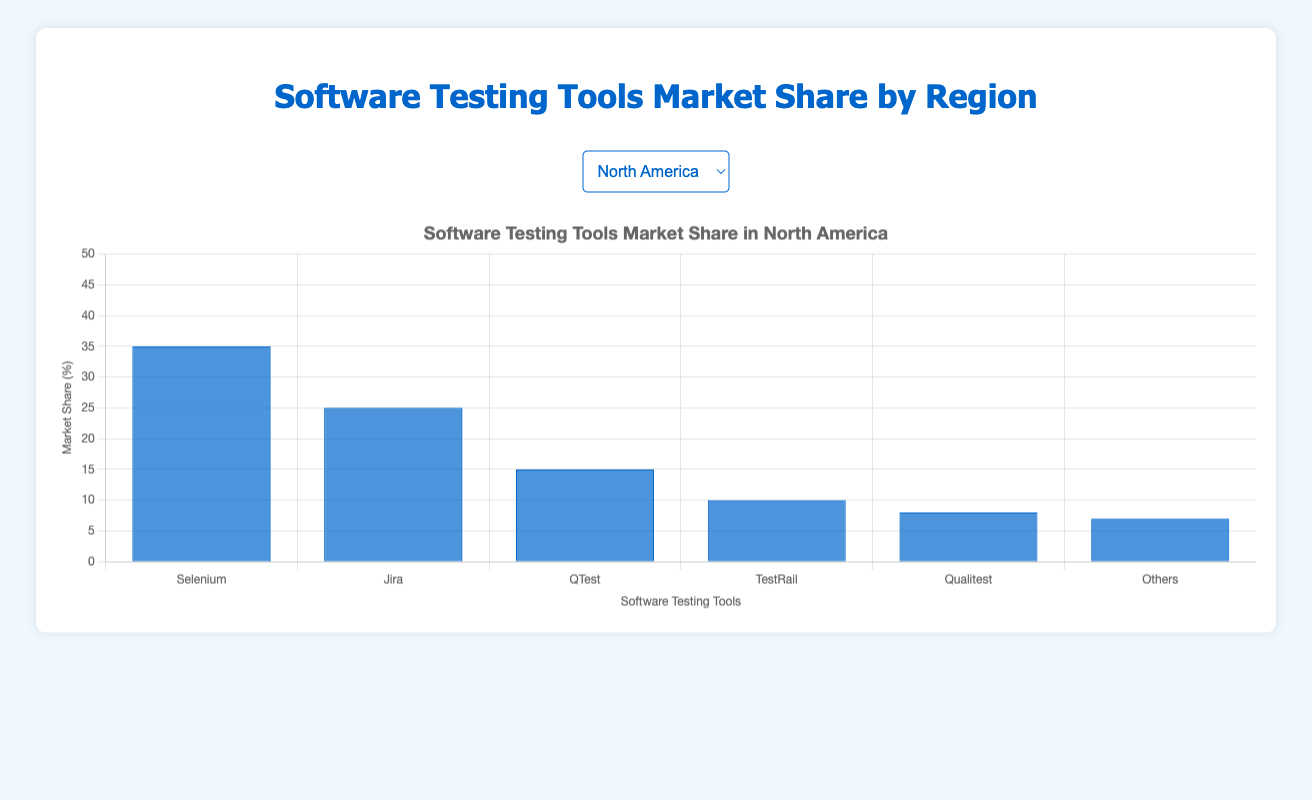Which region has the highest market share for Jira? By visually inspecting the chart for each region, we note the height of the Jira bars. The highest blue bar for Jira appears in North America and Africa, both standing tallest among the regions. Thus, North America and Africa have the highest market shares for Jira.
Answer: North America and Africa Which tool has the lowest market share in South America? Look at the bars representing each tool's market share in South America. The shortest bar belongs to "Others," indicating it has the lowest market share in this region.
Answer: Others What's the combined market share of Selenium and Qualitest in Asia? Observe the height of the bars for Selenium and Qualitest in Asia. Selenium has a market share of 40% and Qualitest has 9%. Adding these two (40 + 9), we get a combined market share of 49%.
Answer: 49% Which tool has the most consistent market share across all regions? Compare the heights of each tool’s bars across all regions. Selenium has consistently high bars in all regions, followed by Jira. However, Selenium shows the least variability in bar heights across all regions, indicating it has the most consistent market share.
Answer: Selenium Which region shows the smallest market share for TestRail? Identify the heights of the bars for TestRail in all regions. The smallest height is observed in North America, with a market share of 10%.
Answer: North America Compare the market share of Qualitest in Africa with that in Oceania. Look at the bars representing Qualitest’s market share in Africa and Oceania. Africa has a market share of 10% while Oceania has 8%. Thus, Africa has a higher market share for Qualitest than Oceania.
Answer: Africa What is the average market share of TestRail across all regions? Find the market share of TestRail in each region: 10, 12, 10, 12, 11, 13. Add these values (10 + 12 + 10 + 12 + 11 + 13) and then divide by the number of regions (6). The sum is 68, so the average is 68/6 ≈ 11.33.
Answer: 11.33 Which region has the highest variance in market share among all tools? To find the region with the highest variance, we need to identify the region where the heights of bars show the largest differences. Asia, with Selenium (40%) and Others (6%), shows significant range differences, indicating high variance.
Answer: Asia 